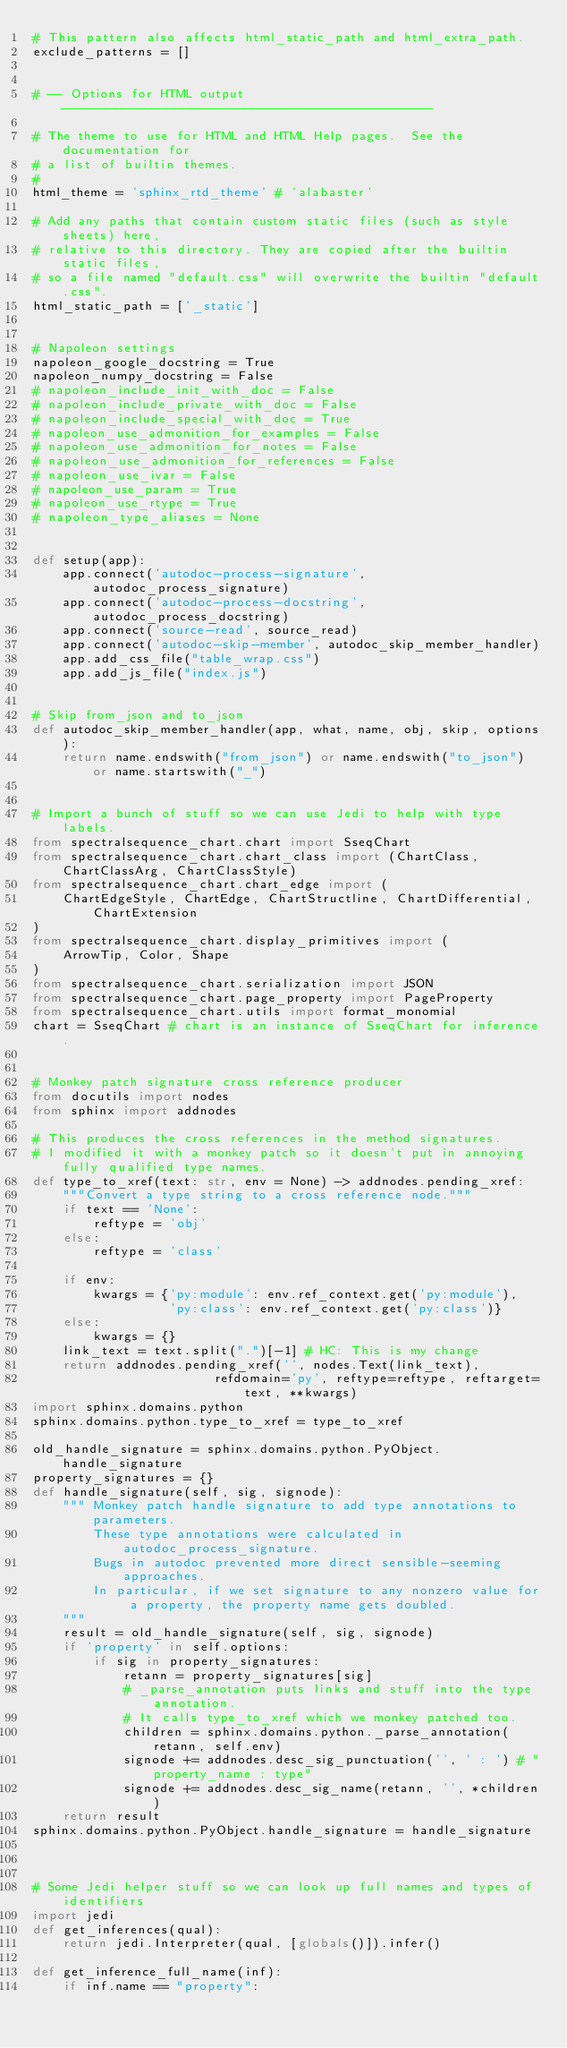<code> <loc_0><loc_0><loc_500><loc_500><_Python_># This pattern also affects html_static_path and html_extra_path.
exclude_patterns = []


# -- Options for HTML output -------------------------------------------------

# The theme to use for HTML and HTML Help pages.  See the documentation for
# a list of builtin themes.
#
html_theme = 'sphinx_rtd_theme' # 'alabaster'

# Add any paths that contain custom static files (such as style sheets) here,
# relative to this directory. They are copied after the builtin static files,
# so a file named "default.css" will overwrite the builtin "default.css".
html_static_path = ['_static']


# Napoleon settings
napoleon_google_docstring = True
napoleon_numpy_docstring = False
# napoleon_include_init_with_doc = False
# napoleon_include_private_with_doc = False
# napoleon_include_special_with_doc = True
# napoleon_use_admonition_for_examples = False
# napoleon_use_admonition_for_notes = False
# napoleon_use_admonition_for_references = False
# napoleon_use_ivar = False
# napoleon_use_param = True
# napoleon_use_rtype = True
# napoleon_type_aliases = None


def setup(app):
    app.connect('autodoc-process-signature', autodoc_process_signature)
    app.connect('autodoc-process-docstring', autodoc_process_docstring)
    app.connect('source-read', source_read)
    app.connect('autodoc-skip-member', autodoc_skip_member_handler)
    app.add_css_file("table_wrap.css")
    app.add_js_file("index.js")


# Skip from_json and to_json
def autodoc_skip_member_handler(app, what, name, obj, skip, options):
    return name.endswith("from_json") or name.endswith("to_json") or name.startswith("_")


# Import a bunch of stuff so we can use Jedi to help with type labels.
from spectralsequence_chart.chart import SseqChart 
from spectralsequence_chart.chart_class import (ChartClass, ChartClassArg, ChartClassStyle)
from spectralsequence_chart.chart_edge import (
    ChartEdgeStyle, ChartEdge, ChartStructline, ChartDifferential, ChartExtension
)
from spectralsequence_chart.display_primitives import (
    ArrowTip, Color, Shape
)
from spectralsequence_chart.serialization import JSON
from spectralsequence_chart.page_property import PageProperty
from spectralsequence_chart.utils import format_monomial
chart = SseqChart # chart is an instance of SseqChart for inference.


# Monkey patch signature cross reference producer
from docutils import nodes
from sphinx import addnodes

# This produces the cross references in the method signatures.
# I modified it with a monkey patch so it doesn't put in annoying fully qualified type names.
def type_to_xref(text: str, env = None) -> addnodes.pending_xref:
    """Convert a type string to a cross reference node."""
    if text == 'None':
        reftype = 'obj'
    else:
        reftype = 'class'

    if env:
        kwargs = {'py:module': env.ref_context.get('py:module'),
                  'py:class': env.ref_context.get('py:class')}
    else:
        kwargs = {}
    link_text = text.split(".")[-1] # HC: This is my change
    return addnodes.pending_xref('', nodes.Text(link_text),
                        refdomain='py', reftype=reftype, reftarget=text, **kwargs)
import sphinx.domains.python
sphinx.domains.python.type_to_xref = type_to_xref

old_handle_signature = sphinx.domains.python.PyObject.handle_signature
property_signatures = {}
def handle_signature(self, sig, signode):
    """ Monkey patch handle signature to add type annotations to parameters.
        These type annotations were calculated in autodoc_process_signature.
        Bugs in autodoc prevented more direct sensible-seeming approaches.
        In particular, if we set signature to any nonzero value for a property, the property name gets doubled.
    """
    result = old_handle_signature(self, sig, signode)
    if 'property' in self.options:
        if sig in property_signatures:
            retann = property_signatures[sig]
            # _parse_annotation puts links and stuff into the type annotation.
            # It calls type_to_xref which we monkey patched too.
            children = sphinx.domains.python._parse_annotation(retann, self.env)
            signode += addnodes.desc_sig_punctuation('', ' : ') # "property_name : type"
            signode += addnodes.desc_sig_name(retann, '', *children)
    return result
sphinx.domains.python.PyObject.handle_signature = handle_signature



# Some Jedi helper stuff so we can look up full names and types of identifiers
import jedi
def get_inferences(qual):
    return jedi.Interpreter(qual, [globals()]).infer()

def get_inference_full_name(inf):
    if inf.name == "property":</code> 